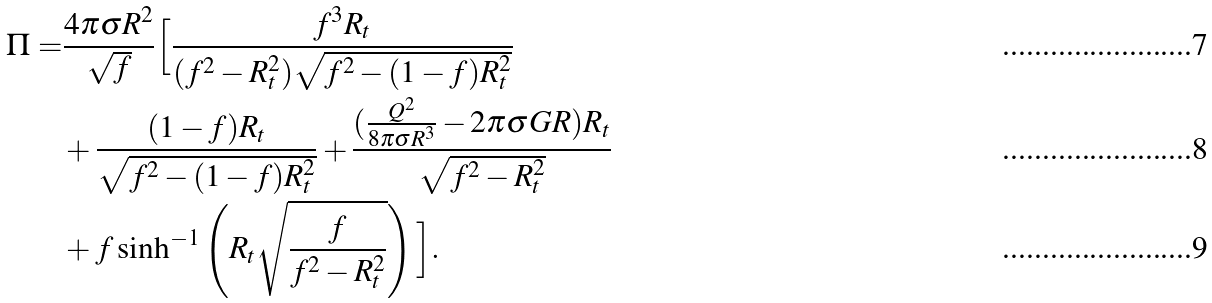<formula> <loc_0><loc_0><loc_500><loc_500>\Pi = & \frac { 4 \pi \sigma R ^ { 2 } } { \sqrt { f } } \Big { [ } \frac { f ^ { 3 } R _ { t } } { ( f ^ { 2 } - R _ { t } ^ { 2 } ) \sqrt { f ^ { 2 } - ( 1 - f ) R _ { t } ^ { 2 } } } \\ & + \frac { ( 1 - f ) R _ { t } } { \sqrt { f ^ { 2 } - ( 1 - f ) R _ { t } ^ { 2 } } } + \frac { ( \frac { Q ^ { 2 } } { 8 \pi \sigma R ^ { 3 } } - 2 \pi \sigma G R ) R _ { t } } { \sqrt { f ^ { 2 } - R _ { t } ^ { 2 } } } \\ & + f \sinh ^ { - 1 } \left ( R _ { t } \sqrt { \frac { f } { f ^ { 2 } - R _ { t } ^ { 2 } } } \right ) \Big { ] } .</formula> 